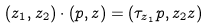<formula> <loc_0><loc_0><loc_500><loc_500>( z _ { 1 } , z _ { 2 } ) \cdot ( p , z ) = ( \tau _ { z _ { 1 } } p , z _ { 2 } z )</formula> 